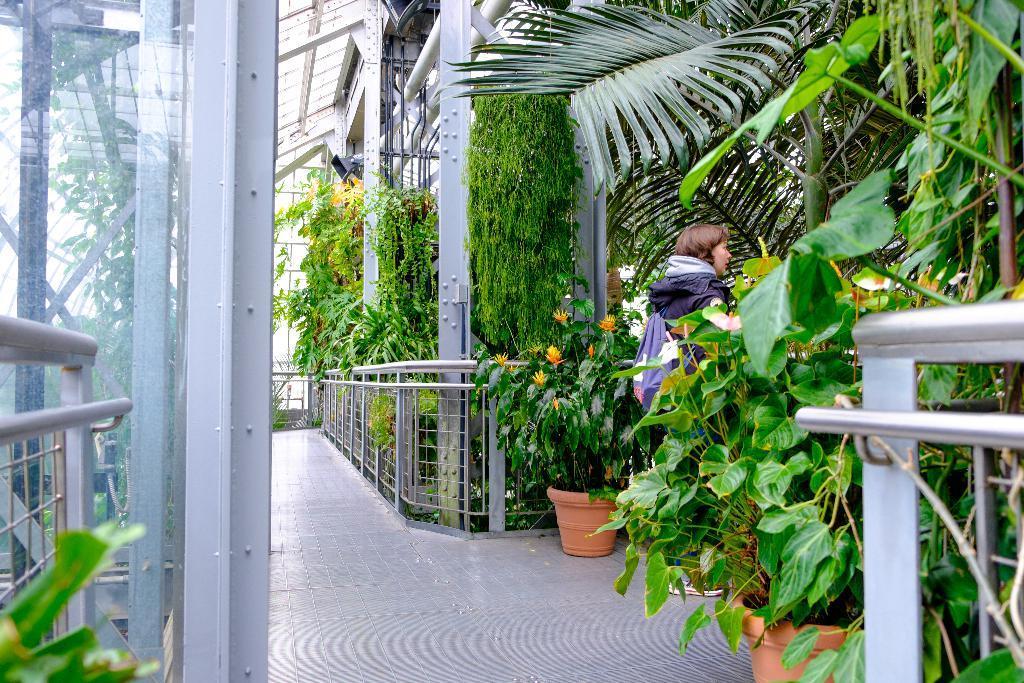How would you summarize this image in a sentence or two? In this image we can see an iron grill, plants, trees, house plant, creepers, floor and a woman a standing near the iron grill. 